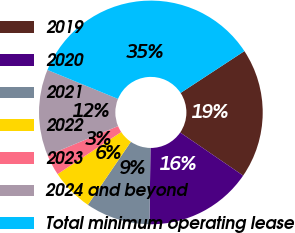Convert chart to OTSL. <chart><loc_0><loc_0><loc_500><loc_500><pie_chart><fcel>2019<fcel>2020<fcel>2021<fcel>2022<fcel>2023<fcel>2024 and beyond<fcel>Total minimum operating lease<nl><fcel>18.79%<fcel>15.64%<fcel>9.33%<fcel>6.18%<fcel>3.02%<fcel>12.48%<fcel>34.56%<nl></chart> 